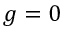Convert formula to latex. <formula><loc_0><loc_0><loc_500><loc_500>g = 0</formula> 